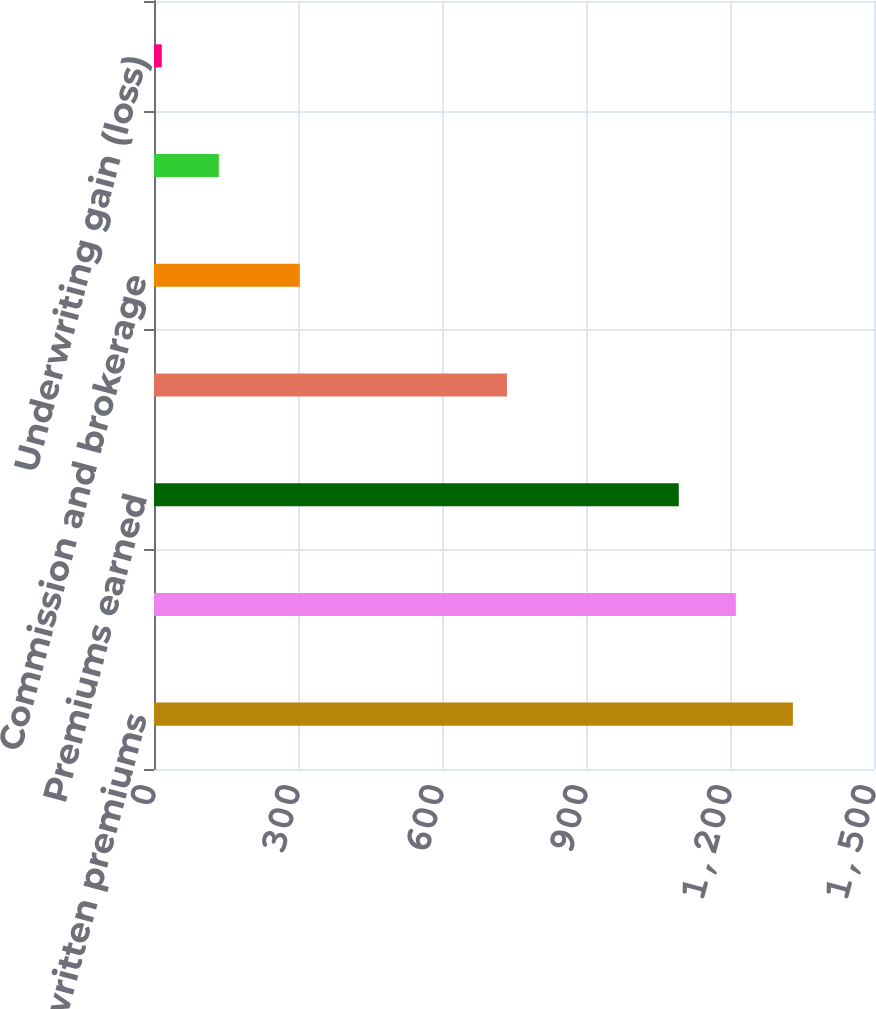Convert chart. <chart><loc_0><loc_0><loc_500><loc_500><bar_chart><fcel>Gross written premiums<fcel>Net written premiums<fcel>Premiums earned<fcel>Incurred losses and LAE<fcel>Commission and brokerage<fcel>Other underwriting expenses<fcel>Underwriting gain (loss)<nl><fcel>1331.06<fcel>1212.18<fcel>1093.3<fcel>735.3<fcel>303.7<fcel>135.08<fcel>16.2<nl></chart> 